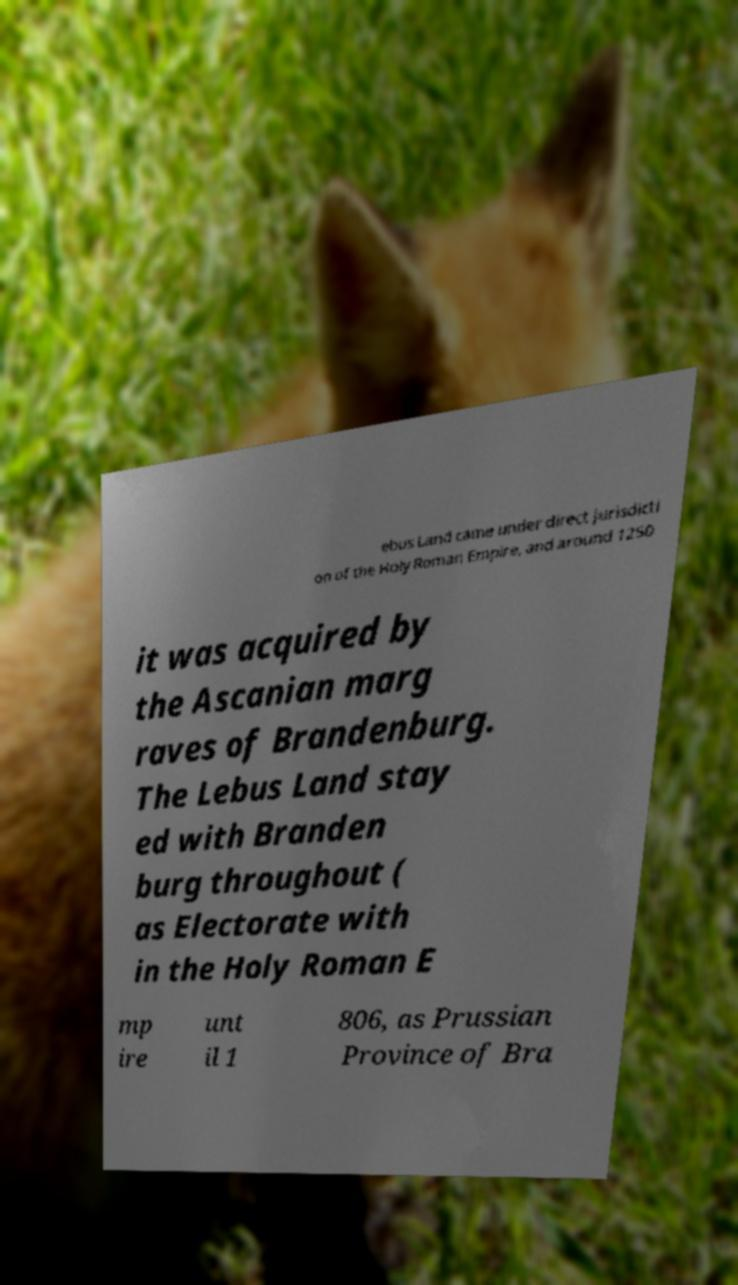Can you read and provide the text displayed in the image?This photo seems to have some interesting text. Can you extract and type it out for me? ebus Land came under direct jurisdicti on of the Holy Roman Empire, and around 1250 it was acquired by the Ascanian marg raves of Brandenburg. The Lebus Land stay ed with Branden burg throughout ( as Electorate with in the Holy Roman E mp ire unt il 1 806, as Prussian Province of Bra 